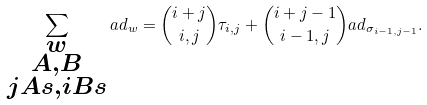<formula> <loc_0><loc_0><loc_500><loc_500>\sum _ { \substack { w \\ A , B \\ j A s , i B s } } a d _ { w } = \binom { i + j } { i , j } \tau _ { i , j } + \binom { i + j - 1 } { i - 1 , j } a d _ { \sigma _ { i - 1 , j - 1 } } .</formula> 